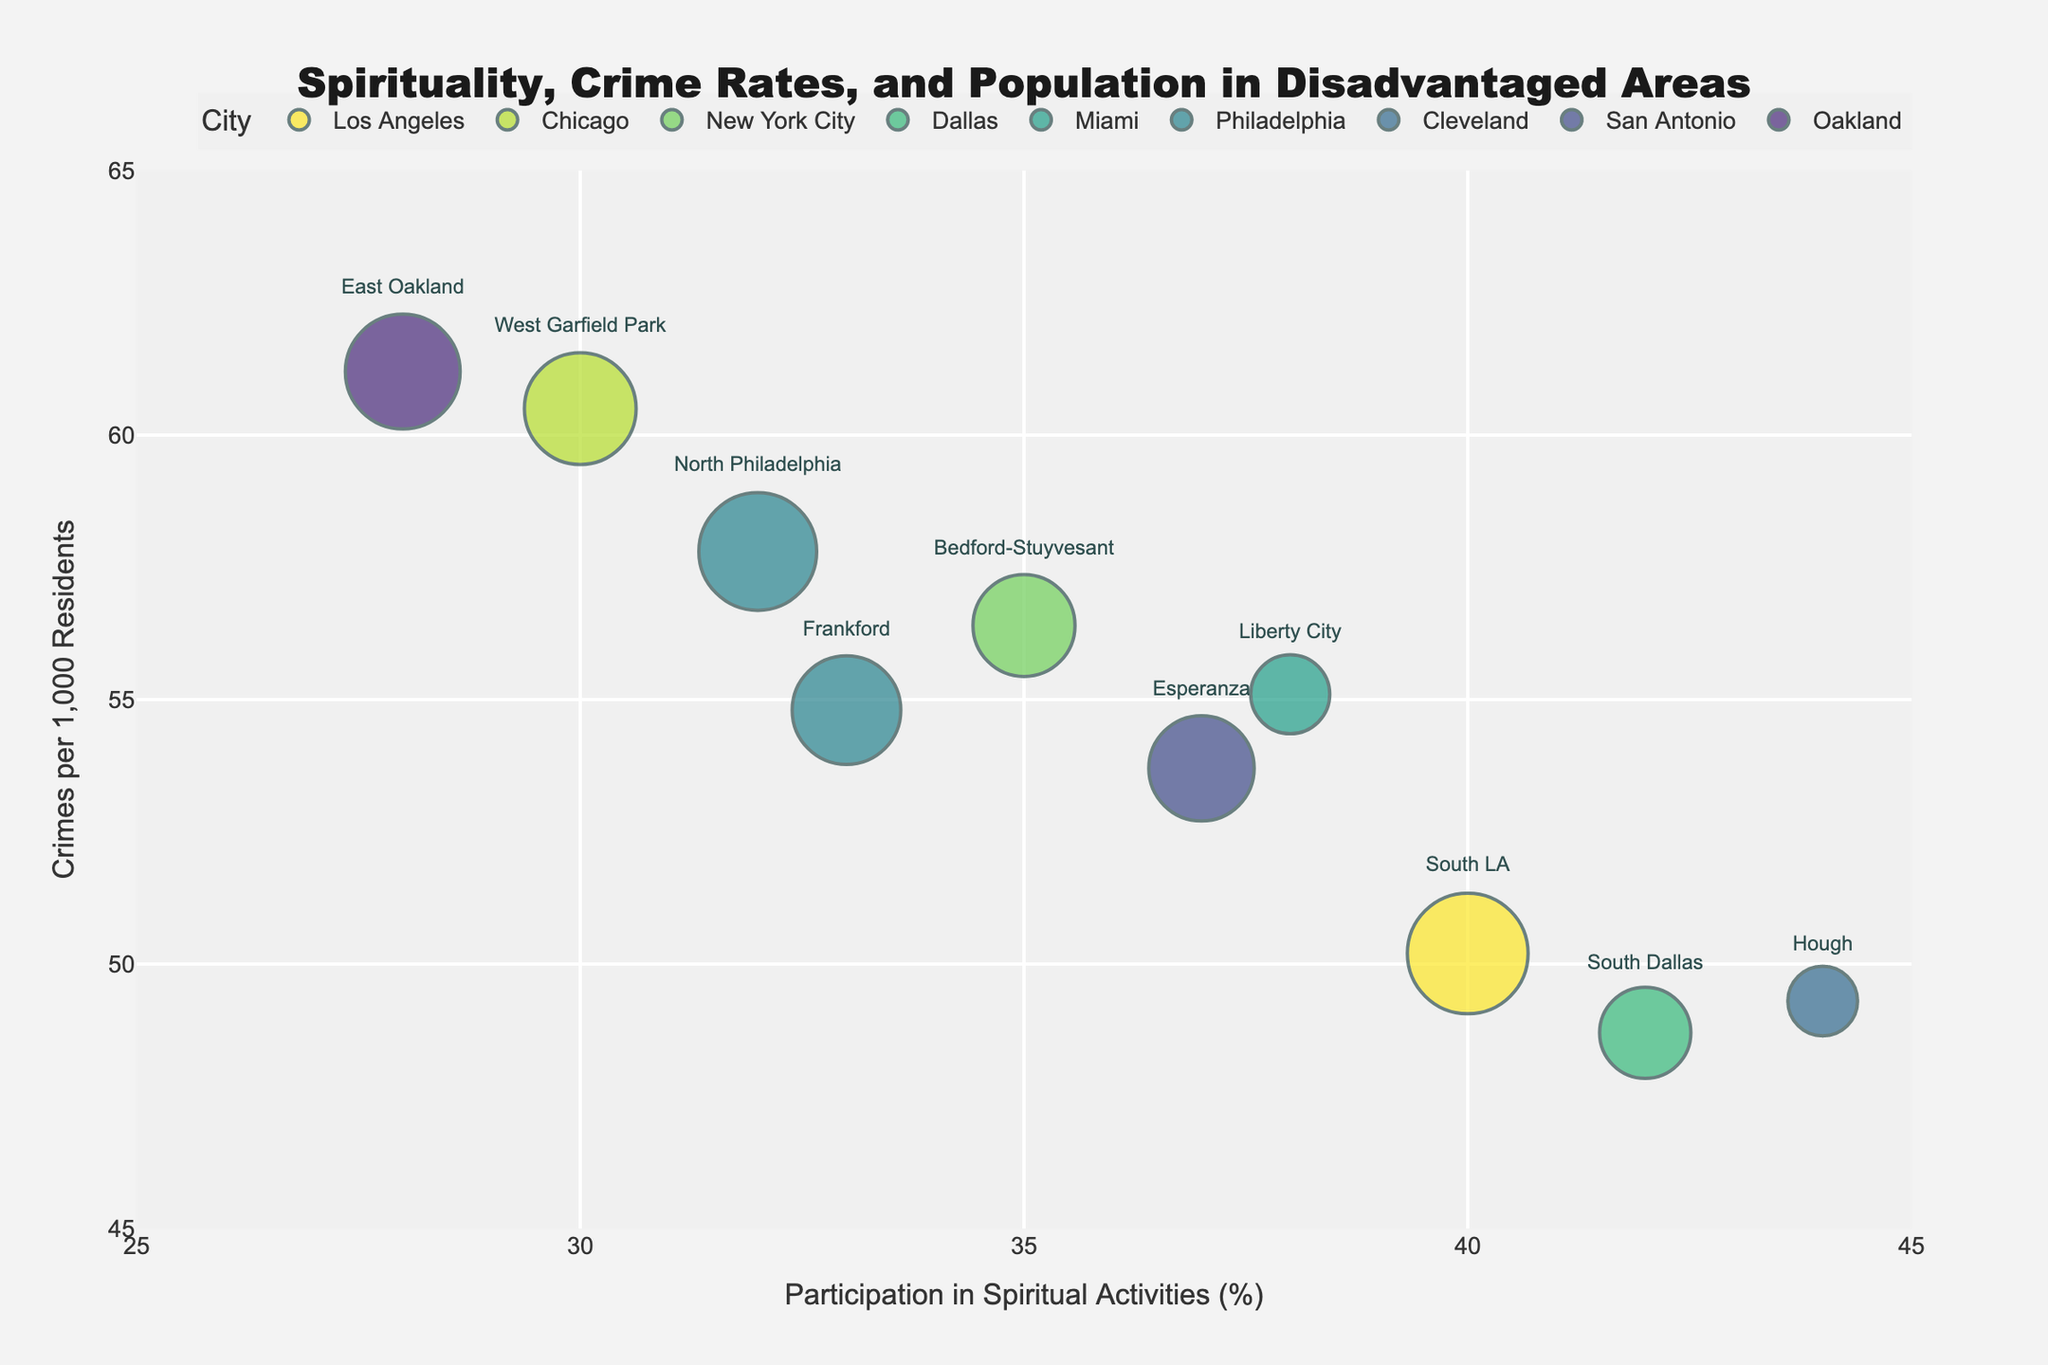What is the title of the chart? The title of the chart is found at the top of the figure and provides an overview of the data being represented. In this case, the title tells us that the chart is about spirituality, crime rates, and population in disadvantaged areas.
Answer: Spirituality, Crime Rates, and Population in Disadvantaged Areas Which area has the highest crime rate per 1000 residents? To identify the area with the highest crime rate per 1000 residents, look for the highest point on the y-axis. From the data, this corresponds to East Oakland, Oakland, which has a crime rate of 61.2 per 1000 residents.
Answer: East Oakland, Oakland What is the range of participation in spiritual activities represented in the chart? The range of participation in spiritual activities is found along the x-axis. It extends from the lowest to the highest value plotted. In this case, the x-axis ranges from 28% to 44% participation.
Answer: 28% to 44% Which city's area has the largest population bubble? The size of the bubbles represents the population. The largest bubble corresponds to North Philadelphia, Philadelphia with a population of 200,000.
Answer: North Philadelphia, Philadelphia How does Liberty City, Miami compare to Esperanza, San Antonio in terms of crime rate and participation in spiritual activities? Liberty City, Miami has a crime rate of 55.1 crimes per 1000 residents and 38% participation in spiritual activities. Esperanza, San Antonio has a crime rate of 53.7 crimes per 1000 residents and 37% participation in spiritual activities. Thus, Liberty City has a slightly higher crime rate and participation in spiritual activities than Esperanza.
Answer: Liberty City has a higher crime rate and participation What is the average crime rate per 1000 residents across all areas? To compute the average crime rate, sum up all the crime rates and divide by the number of areas. The sum is (50.2 + 60.5 + 56.4 + 48.7 + 55.1 + 57.8 + 49.3 + 53.7 + 61.2 + 54.8) = 547.7. There are 10 areas, so the average is 547.7 / 10 = 54.77.
Answer: 54.77 Which area has the lowest participation in spiritual activities? The lowest point on the x-axis represents the area with the lowest participation in spiritual activities. This corresponds to East Oakland, Oakland with 28% participation.
Answer: East Oakland, Oakland What is the correlation trend between population size and crime rate? Observing the bubble sizes and their vertical positions on the y-axis, it appears that there is no clear direct correlation between population size and crime rate. Areas with varying population sizes are scattered across different crime rates.
Answer: No clear correlation How many areas have a participation rate in spiritual activities above 40%? By identifying the data points above the 40% mark on the x-axis, there are two areas: South LA, Los Angeles (40%), and South Dallas, Dallas (42%), and Hough, Cleveland (44%).
Answer: Three areas 